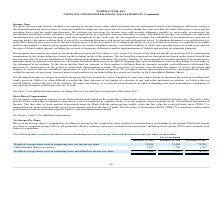According to Formfactor's financial document, What is the Weighted-average shares used in computing basic and diluted net income per share in 2019? According to the financial document, 77,286 (in thousands). The relevant text states: "computing basic and diluted net income per share 77,286 75,182 74,239..." Also, can you calculate: What is the change in Weighted-average shares used in computing basic net income per share from Fiscal Year Ended December 28, 2019 to December 29, 2018? Based on the calculation: 74,994-73,482, the result is 1512 (in thousands). This is based on the information: "ares used in computing basic net income per share 74,994 73,482 72,292 ed in computing basic net income per share 74,994 73,482 72,292..." The key data points involved are: 73,482, 74,994. Also, can you calculate: What is the change in Weighted-average shares used in computing basic and diluted net income per share from Fiscal Year Ended December 28, 2019 to December 29, 2018? Based on the calculation: 77,286-75,182, the result is 2104 (in thousands). This is based on the information: "ing basic and diluted net income per share 77,286 75,182 74,239 computing basic and diluted net income per share 77,286 75,182 74,239..." The key data points involved are: 75,182, 77,286. Additionally, In which year was Add potentially dilutive securities less than 2,000 thousands? The document shows two values: 2018 and 2017. Locate and analyze add potentially dilutive securities in row 4. From the document: "December 28, 2019 December 29, 2018 December 30, 2017 December 28, 2019 December 29, 2018 December 30, 2017..." Also, What was the Weighted-average shares used in computing basic net income per share in 2019, 2018 and 2017 respectively? The document contains multiple relevant values: 74,994, 73,482, 72,292 (in thousands). From the document: "omputing basic net income per share 74,994 73,482 72,292 ares used in computing basic net income per share 74,994 73,482 72,292 ed in computing basic ..." Also, How is the basic net income per share calculated? computed by dividing net income by the weighted-average number of common shares outstanding for the period.. The document states: "Net Income Per Share Basic net income per share is computed by dividing net income by the weighted-average number of common shares outstanding for the..." 